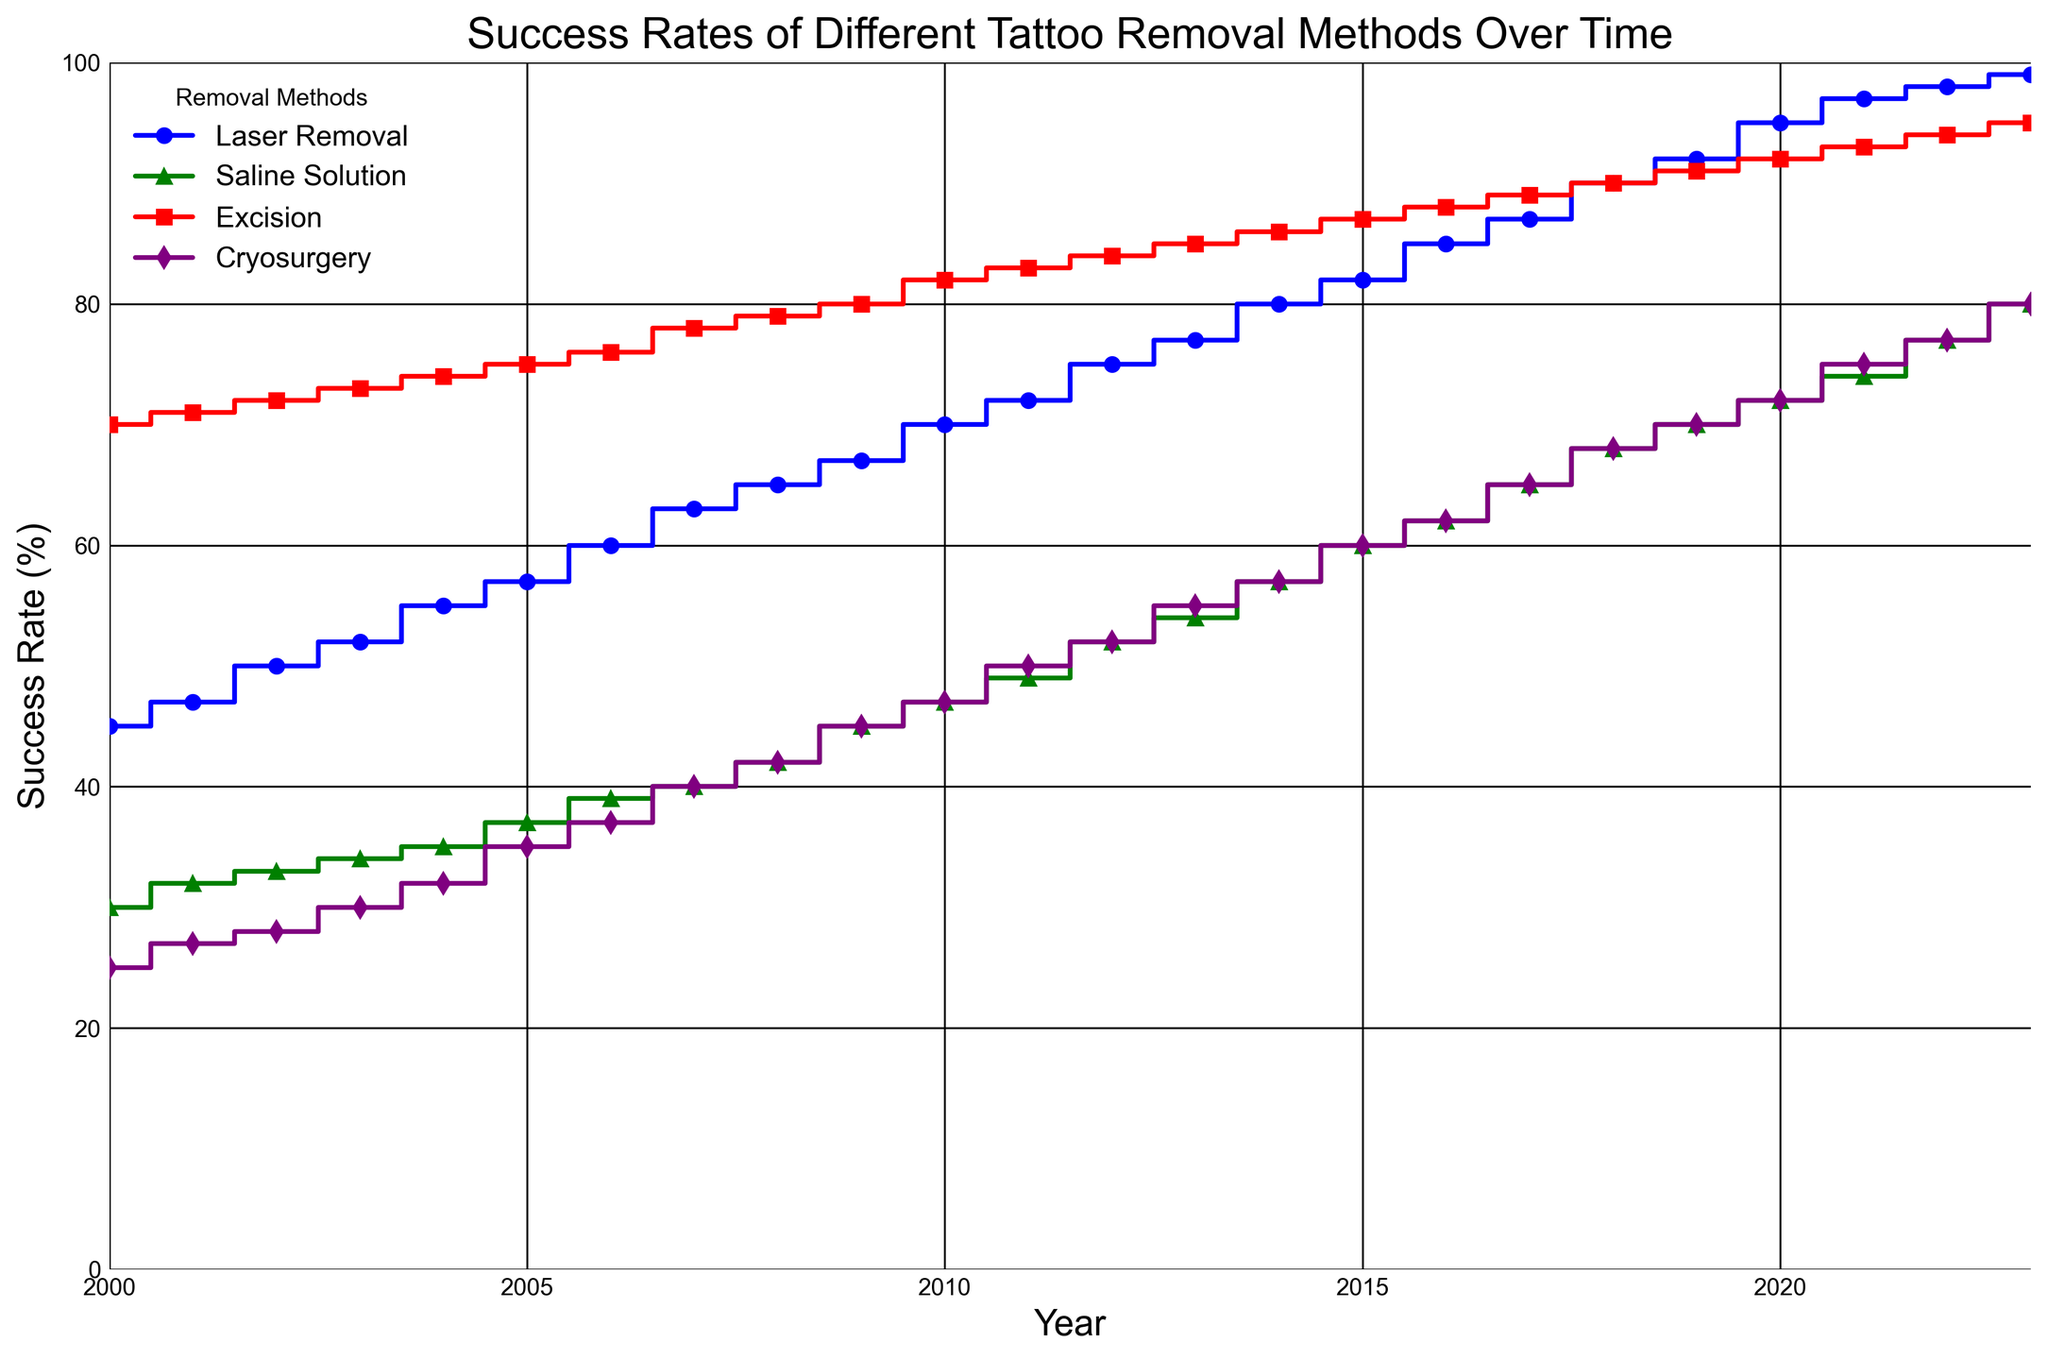Which tattoo removal method had the highest success rate in 2023? To determine the highest success rate in 2023, look at the values for all methods in that year. Laser Removal: 99%, Saline Solution: 80%, Excision: 95%, Cryosurgery: 80%. The highest value is for Laser Removal.
Answer: Laser Removal How did the success rate of Cryosurgery change from 2000 to 2005? To find the change, subtract the value in 2000 from the value in 2005. Cryosurgery in 2000: 25%, Cryosurgery in 2005: 35%. The change is 35% - 25% = 10%.
Answer: Increased by 10% Which method showed the most consistent increase in success rate over the years? To determine consistency, look at the trends in the plot for each method. Laser Removal shows a steady increase from 45% in 2000 to 99% in 2023. Saline Solution, Excision, and Cryosurgery show more variability.
Answer: Laser Removal In which year did Excision first achieve a success rate of 80% or more? Look at the values for Excision to find when it reaches 80% or more. Excision reaches 80% in 2009.
Answer: 2009 Compare the success rate trends of Laser Removal and Saline Solution from 2010 to 2020. Which one had a steeper increase? Calculate the difference between 2010 and 2020 for both methods. Laser Removal: 95% - 70% = 25%. Saline Solution: 72% - 47% = 25%. The increase is the same for both methods.
Answer: Equal Which method had the least success rate in the year 2013? Look at the values for all methods in 2013: Laser Removal: 77%, Saline Solution: 54%, Excision: 85%, Cryosurgery: 55%. The lowest value is for Saline Solution.
Answer: Saline Solution What was the average success rate of Saline Solution from 2018 to 2023? Sum the values of Saline Solution from 2018 to 2023 and divide by the number of years. (68% + 70% + 72% + 74% + 77% + 80%) / 6 = 73.5%.
Answer: 73.5% Identify the year when Cryosurgery surpassed a 50% success rate. Look at the Cryosurgery values to find when it first surpasses 50%. This occurs in 2011 when it reaches 50%.
Answer: 2011 Which method had the fastest growth in success rate between 2000 and 2023? Calculate the difference between 2000 and 2023 for each method and compare. Laser Removal: 99% - 45% = 54%, Saline Solution: 80% - 30% = 50%, Excision: 95% - 70% = 25%, Cryosurgery: 80% - 25% = 55%. The fastest growth was in Cryosurgery with 55%.
Answer: Cryosurgery 